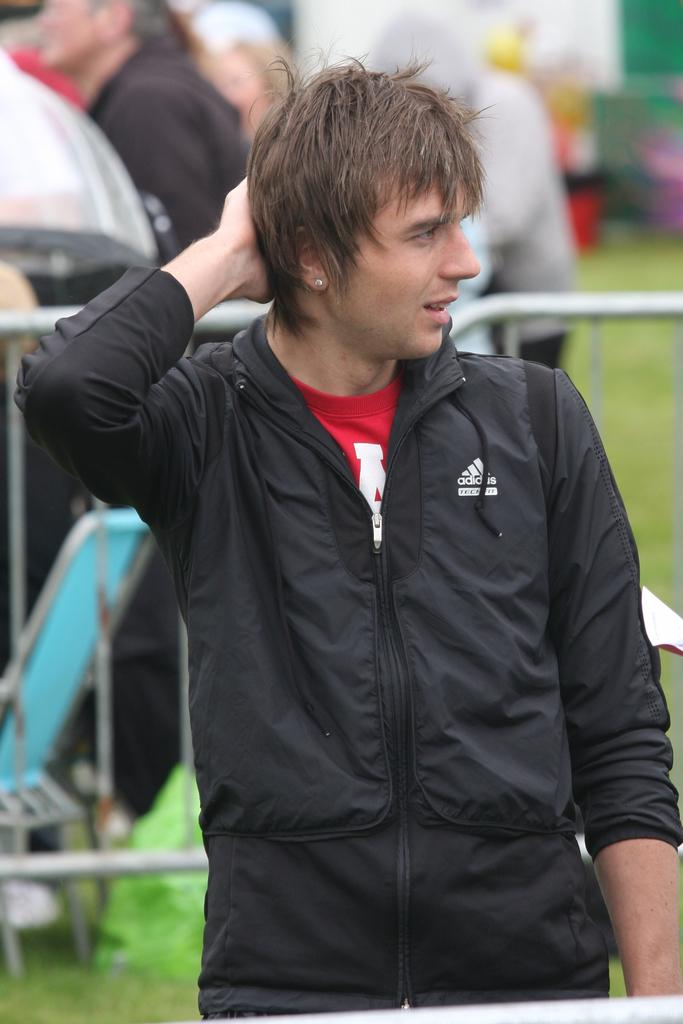What can be seen in the background of the image? In the background of the image, there are people, grass, and a railing. Can you describe the man in the image? The man in the image is wearing a black jacket and a red t-shirt, and he is standing. What is the plot of the story being told in the image? There is no story being told in the image, as it is a still photograph. Can you describe the man's ear in the image? There is no specific detail about the man's ear provided in the image, so it cannot be described. 